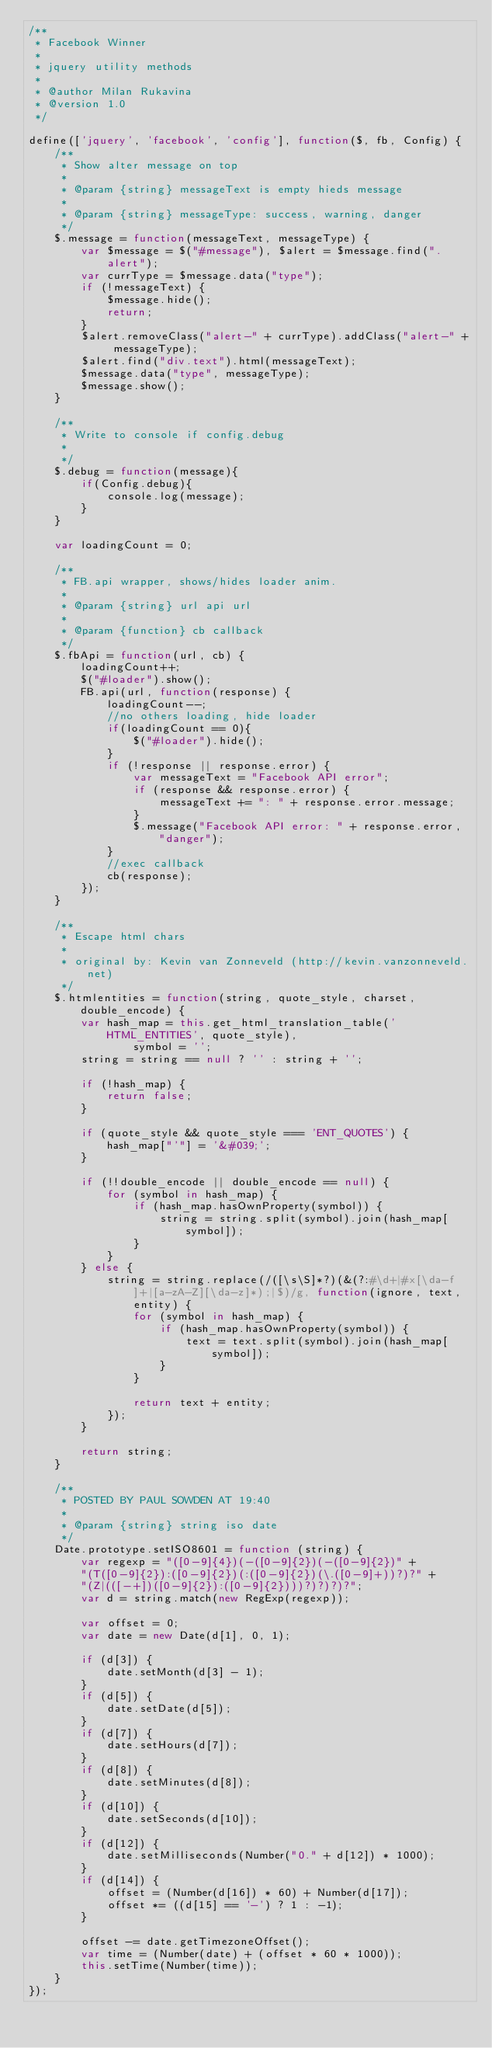<code> <loc_0><loc_0><loc_500><loc_500><_JavaScript_>/**
 * Facebook Winner
 *
 * jquery utility methods
 *
 * @author Milan Rukavina
 * @version 1.0
 */

define(['jquery', 'facebook', 'config'], function($, fb, Config) {
    /**
     * Show alter message on top
     *
     * @param {string} messageText is empty hieds message
     * 
     * @param {string} messageType: success, warning, danger
     */
    $.message = function(messageText, messageType) {
        var $message = $("#message"), $alert = $message.find(".alert");
        var currType = $message.data("type");
        if (!messageText) {
            $message.hide();
            return;
        }
        $alert.removeClass("alert-" + currType).addClass("alert-" + messageType);
        $alert.find("div.text").html(messageText);
        $message.data("type", messageType);
        $message.show();
    }

    /**
     * Write to console if config.debug
     *
     */
    $.debug = function(message){
        if(Config.debug){
            console.log(message);
        }
    }
    
    var loadingCount = 0;

    /**
     * FB.api wrapper, shows/hides loader anim.
     *
     * @param {string} url api url
     *
     * @param {function} cb callback
     */
    $.fbApi = function(url, cb) {
        loadingCount++;
        $("#loader").show();
        FB.api(url, function(response) {
            loadingCount--;
            //no others loading, hide loader
            if(loadingCount == 0){
                $("#loader").hide();
            }
            if (!response || response.error) {
                var messageText = "Facebook API error";
                if (response && response.error) {
                    messageText += ": " + response.error.message;
                }
                $.message("Facebook API error: " + response.error, "danger");
            }
            //exec callback
            cb(response);
        });
    }

    /**
     * Escape html chars
     * 
     * original by: Kevin van Zonneveld (http://kevin.vanzonneveld.net)
     */
    $.htmlentities = function(string, quote_style, charset, double_encode) {
        var hash_map = this.get_html_translation_table('HTML_ENTITIES', quote_style),
                symbol = '';
        string = string == null ? '' : string + '';

        if (!hash_map) {
            return false;
        }

        if (quote_style && quote_style === 'ENT_QUOTES') {
            hash_map["'"] = '&#039;';
        }

        if (!!double_encode || double_encode == null) {
            for (symbol in hash_map) {
                if (hash_map.hasOwnProperty(symbol)) {
                    string = string.split(symbol).join(hash_map[symbol]);
                }
            }
        } else {
            string = string.replace(/([\s\S]*?)(&(?:#\d+|#x[\da-f]+|[a-zA-Z][\da-z]*);|$)/g, function(ignore, text, entity) {
                for (symbol in hash_map) {
                    if (hash_map.hasOwnProperty(symbol)) {
                        text = text.split(symbol).join(hash_map[symbol]);
                    }
                }

                return text + entity;
            });
        }

        return string;
    }

    /**
     * POSTED BY PAUL SOWDEN AT 19:40
     *
     * @param {string} string iso date
     */
    Date.prototype.setISO8601 = function (string) {
        var regexp = "([0-9]{4})(-([0-9]{2})(-([0-9]{2})" +
        "(T([0-9]{2}):([0-9]{2})(:([0-9]{2})(\.([0-9]+))?)?" +
        "(Z|(([-+])([0-9]{2}):([0-9]{2})))?)?)?)?";
        var d = string.match(new RegExp(regexp));

        var offset = 0;
        var date = new Date(d[1], 0, 1);

        if (d[3]) {
            date.setMonth(d[3] - 1);
        }
        if (d[5]) {
            date.setDate(d[5]);
        }
        if (d[7]) {
            date.setHours(d[7]);
        }
        if (d[8]) {
            date.setMinutes(d[8]);
        }
        if (d[10]) {
            date.setSeconds(d[10]);
        }
        if (d[12]) {
            date.setMilliseconds(Number("0." + d[12]) * 1000);
        }
        if (d[14]) {
            offset = (Number(d[16]) * 60) + Number(d[17]);
            offset *= ((d[15] == '-') ? 1 : -1);
        }

        offset -= date.getTimezoneOffset();
        var time = (Number(date) + (offset * 60 * 1000));
        this.setTime(Number(time));
    }
});</code> 